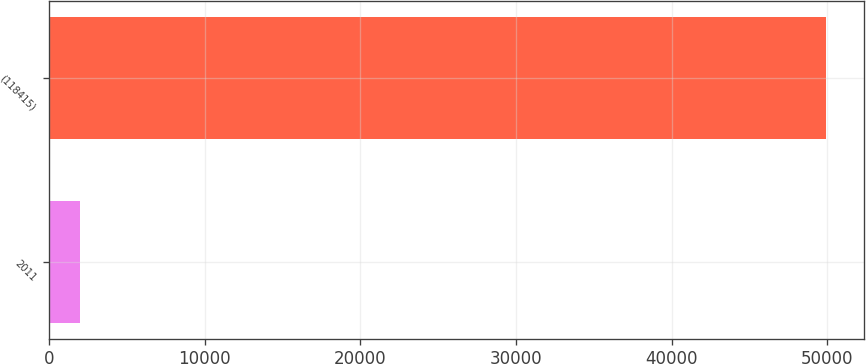Convert chart. <chart><loc_0><loc_0><loc_500><loc_500><bar_chart><fcel>2011<fcel>(118415)<nl><fcel>2010<fcel>49887<nl></chart> 